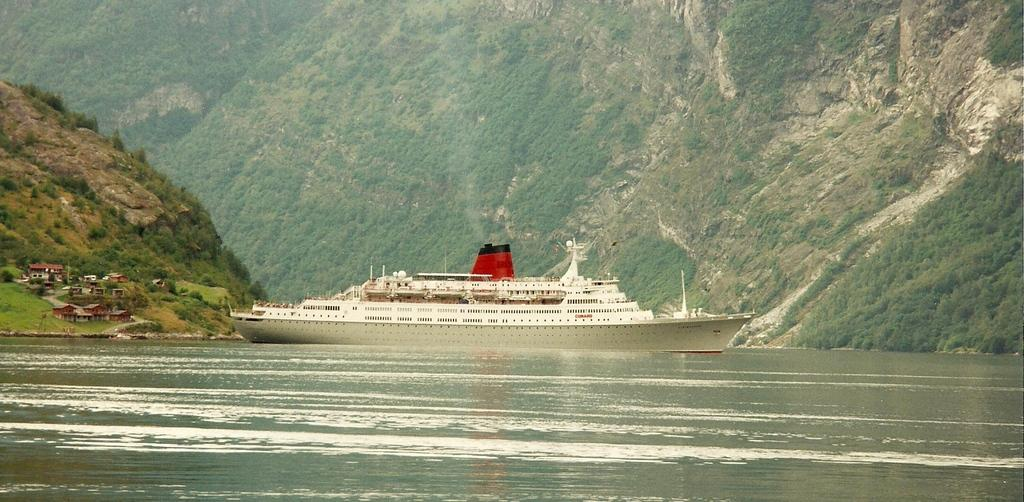What is the main subject of the image? The main subject of the image is a ship on the water. What other structures or elements can be seen in the image? There are houses, grass, trees, and a mountain in the background of the image. What type of toothpaste is being used to clean the ship's hull in the image? There is no toothpaste present in the image, and the ship's hull is not being cleaned. What type of motion is the ship exhibiting in the image? The image does not show the ship in motion; it is stationary on the water. 